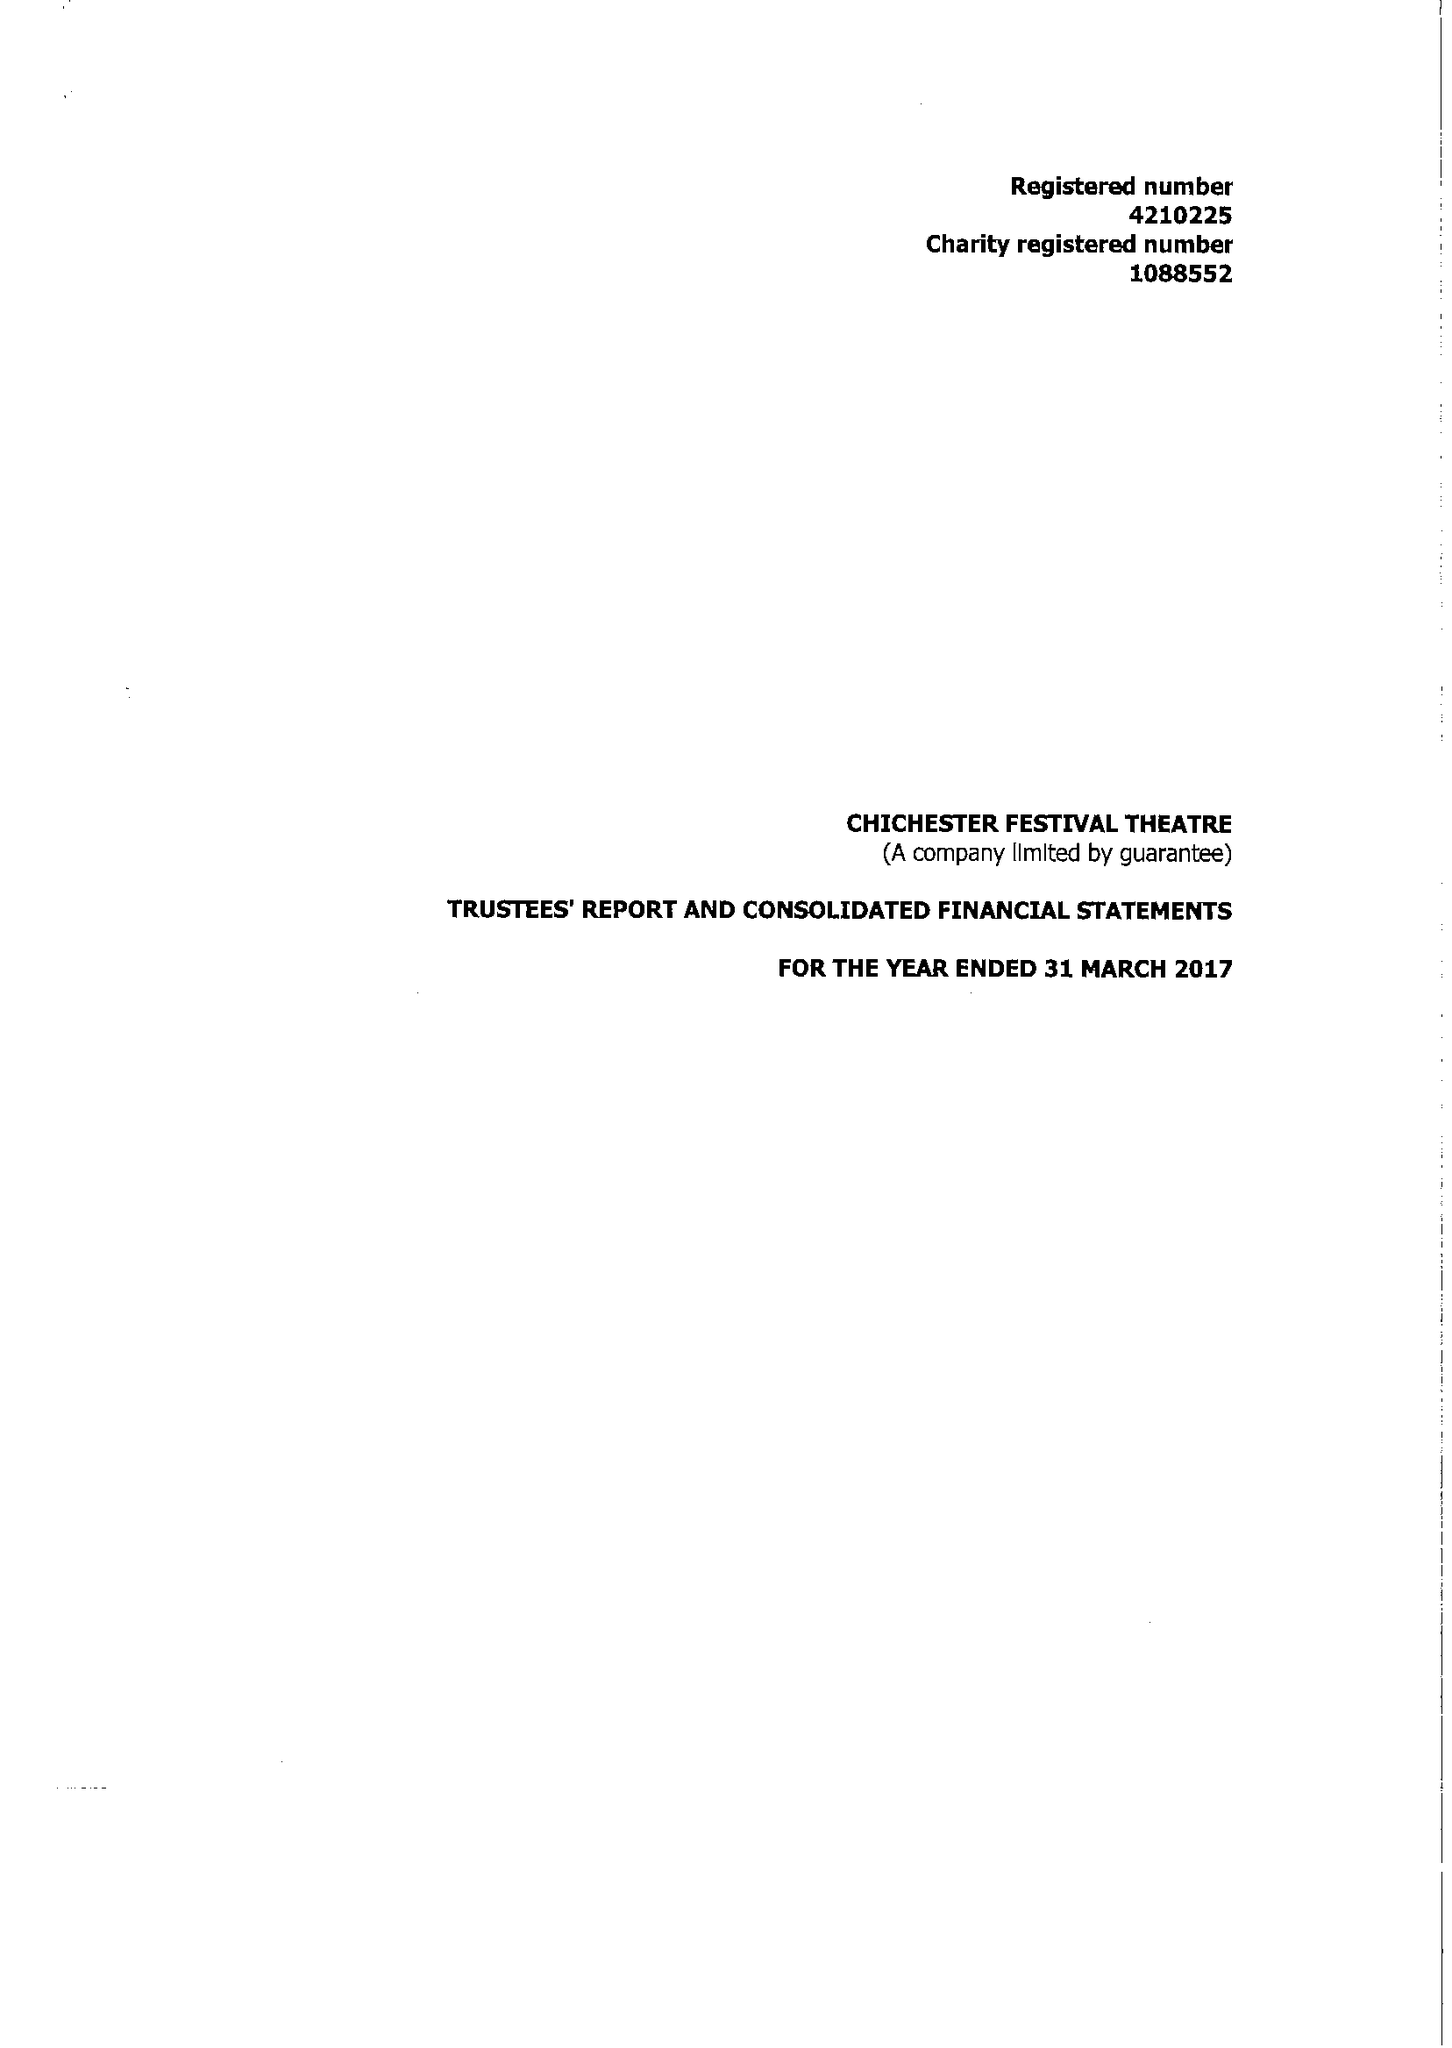What is the value for the spending_annually_in_british_pounds?
Answer the question using a single word or phrase. 17158604.00 